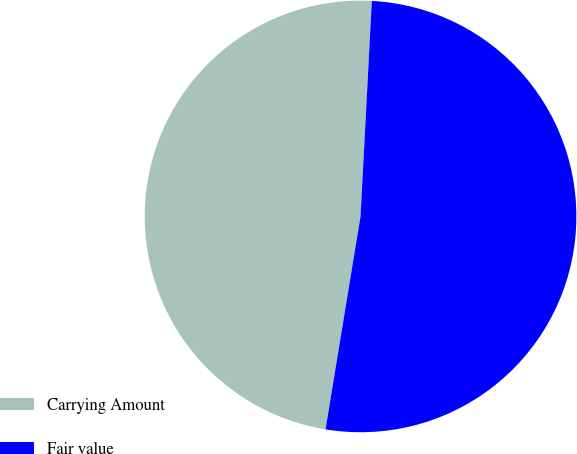Convert chart. <chart><loc_0><loc_0><loc_500><loc_500><pie_chart><fcel>Carrying Amount<fcel>Fair value<nl><fcel>48.24%<fcel>51.76%<nl></chart> 